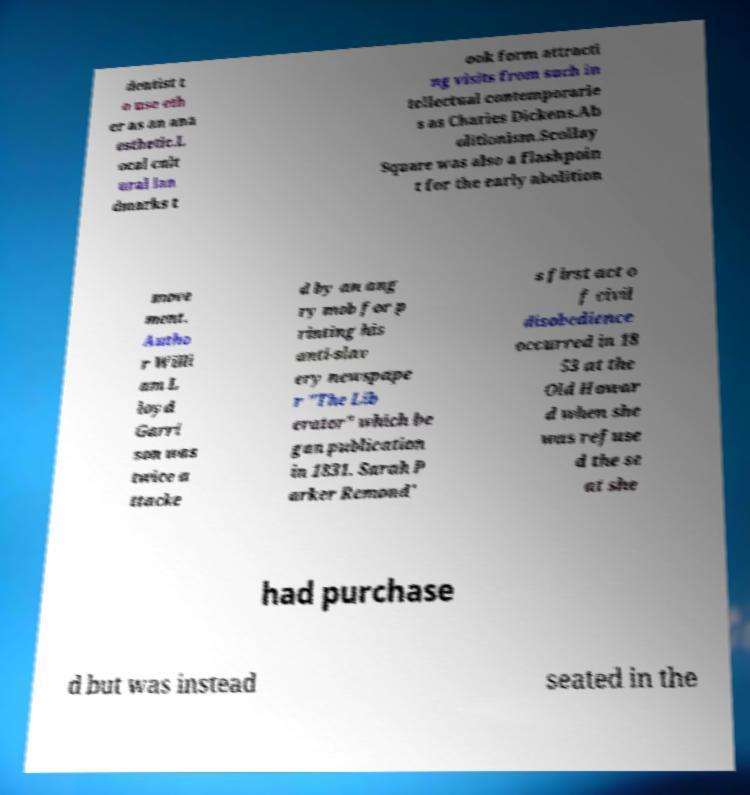For documentation purposes, I need the text within this image transcribed. Could you provide that? dentist t o use eth er as an ana esthetic.L ocal cult ural lan dmarks t ook form attracti ng visits from such in tellectual contemporarie s as Charles Dickens.Ab olitionism.Scollay Square was also a flashpoin t for the early abolition move ment. Autho r Willi am L loyd Garri son was twice a ttacke d by an ang ry mob for p rinting his anti-slav ery newspape r "The Lib erator" which be gan publication in 1831. Sarah P arker Remond' s first act o f civil disobedience occurred in 18 53 at the Old Howar d when she was refuse d the se at she had purchase d but was instead seated in the 